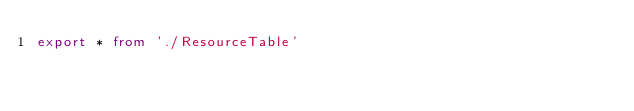Convert code to text. <code><loc_0><loc_0><loc_500><loc_500><_TypeScript_>export * from './ResourceTable'
</code> 